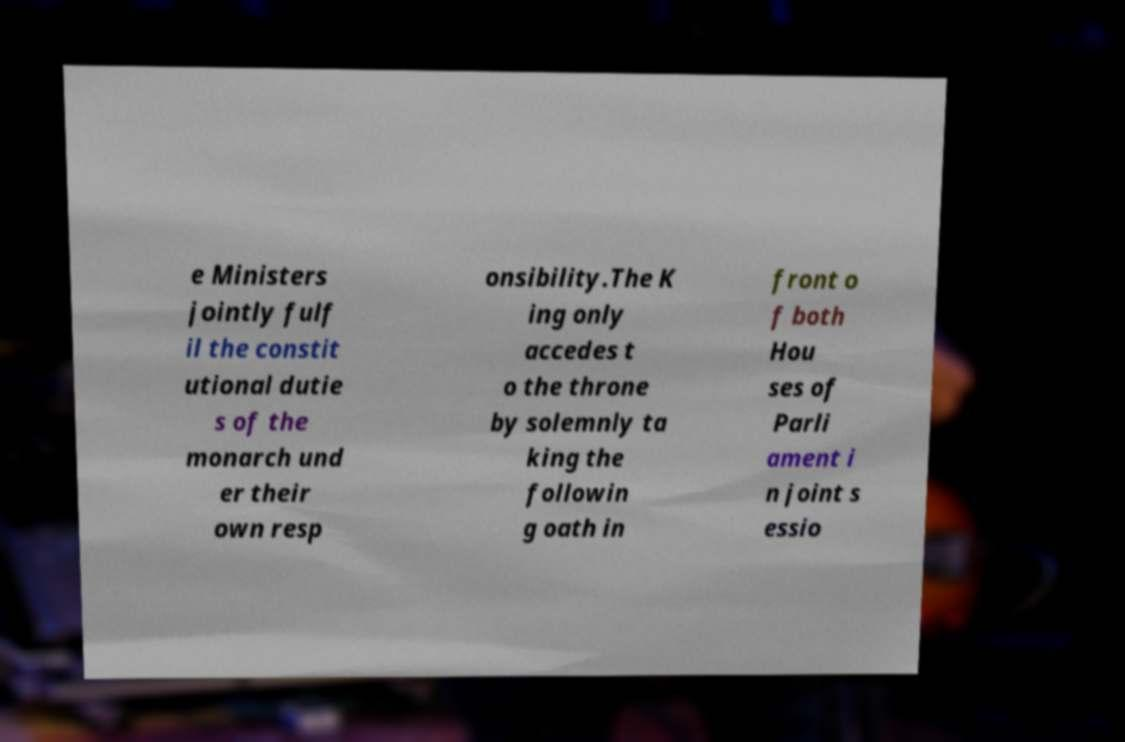There's text embedded in this image that I need extracted. Can you transcribe it verbatim? e Ministers jointly fulf il the constit utional dutie s of the monarch und er their own resp onsibility.The K ing only accedes t o the throne by solemnly ta king the followin g oath in front o f both Hou ses of Parli ament i n joint s essio 